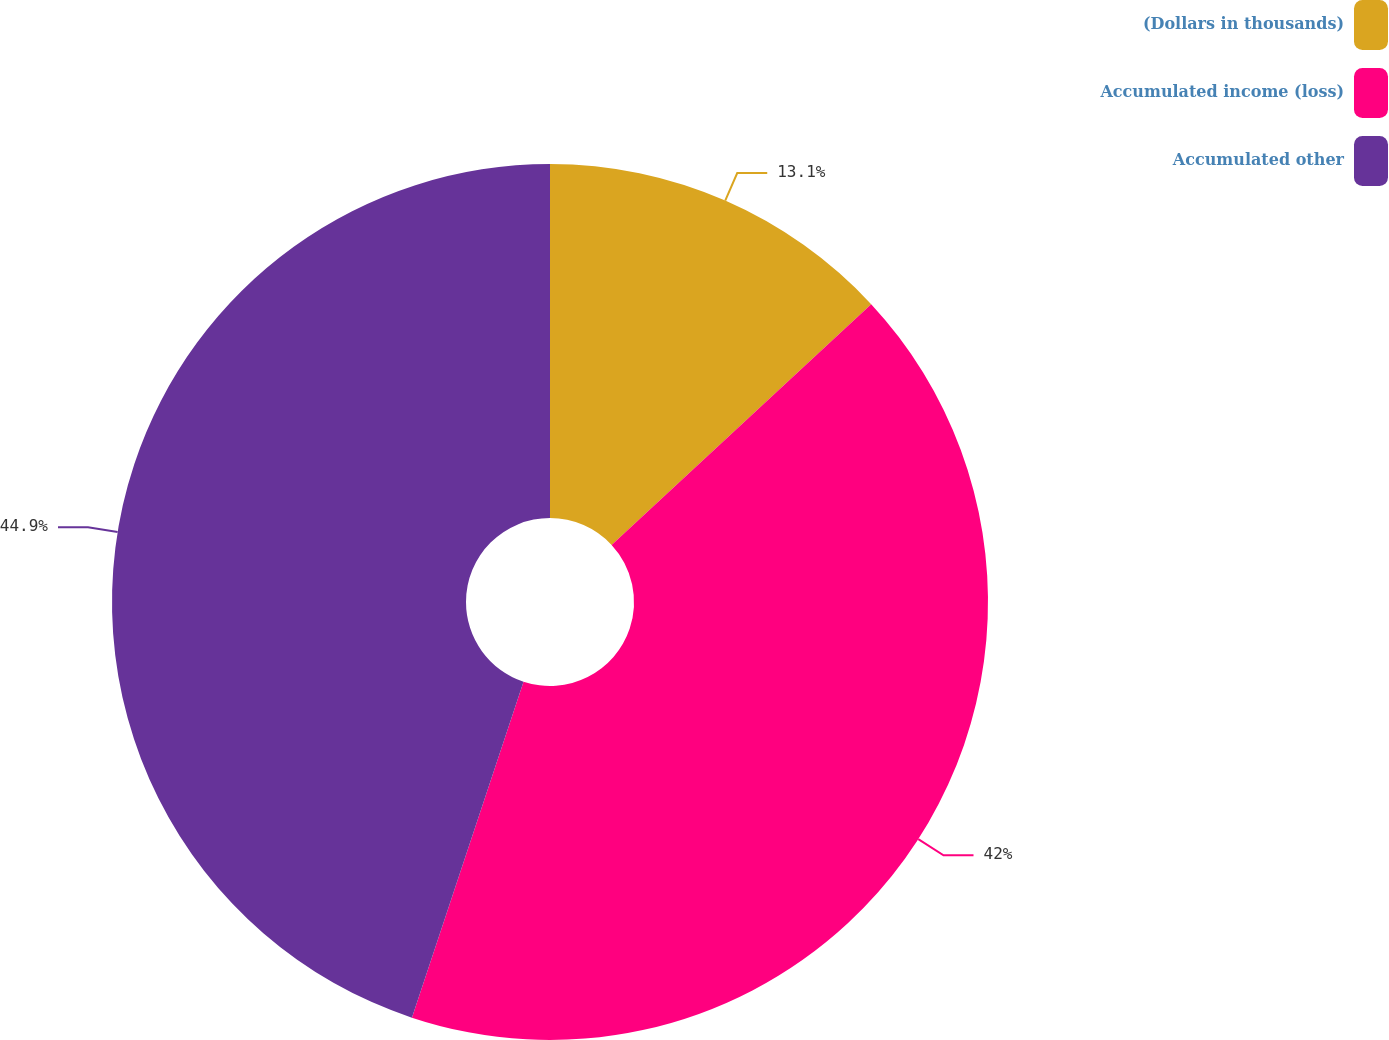Convert chart. <chart><loc_0><loc_0><loc_500><loc_500><pie_chart><fcel>(Dollars in thousands)<fcel>Accumulated income (loss)<fcel>Accumulated other<nl><fcel>13.1%<fcel>42.0%<fcel>44.89%<nl></chart> 